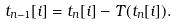Convert formula to latex. <formula><loc_0><loc_0><loc_500><loc_500>t _ { n - 1 } [ i ] = t _ { n } [ i ] - T ( t _ { n } [ i ] ) .</formula> 